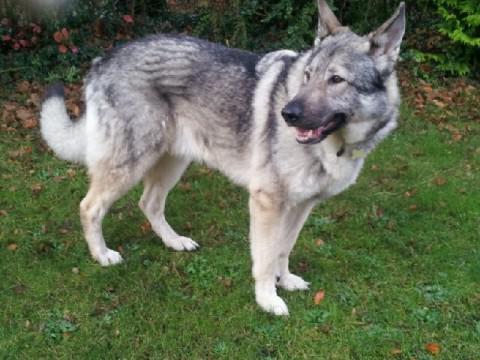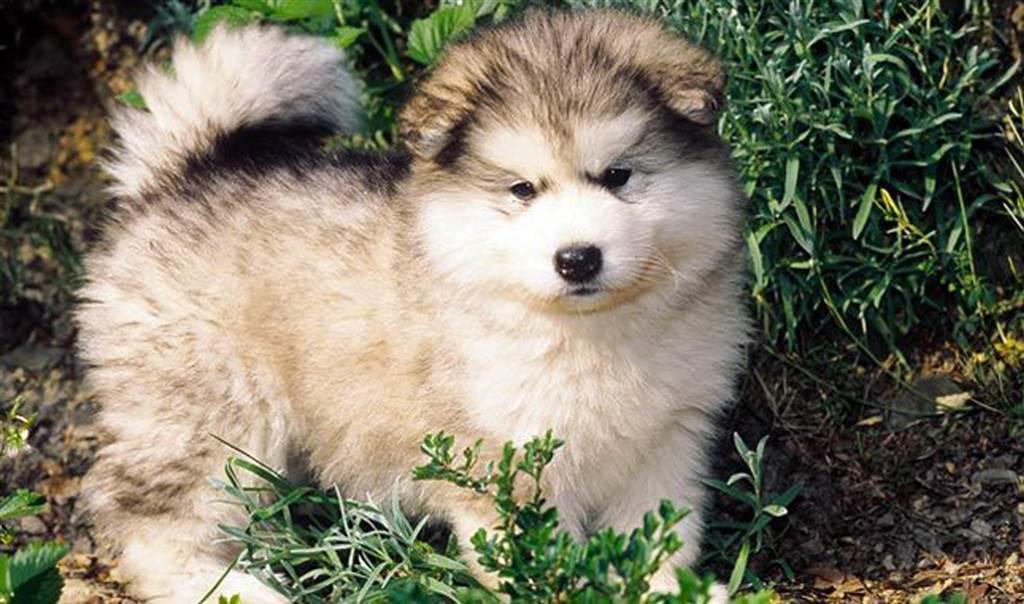The first image is the image on the left, the second image is the image on the right. Evaluate the accuracy of this statement regarding the images: "A dog is standing in the grass.". Is it true? Answer yes or no. Yes. The first image is the image on the left, the second image is the image on the right. Given the left and right images, does the statement "The left and right image contains the same number of dogs." hold true? Answer yes or no. Yes. 